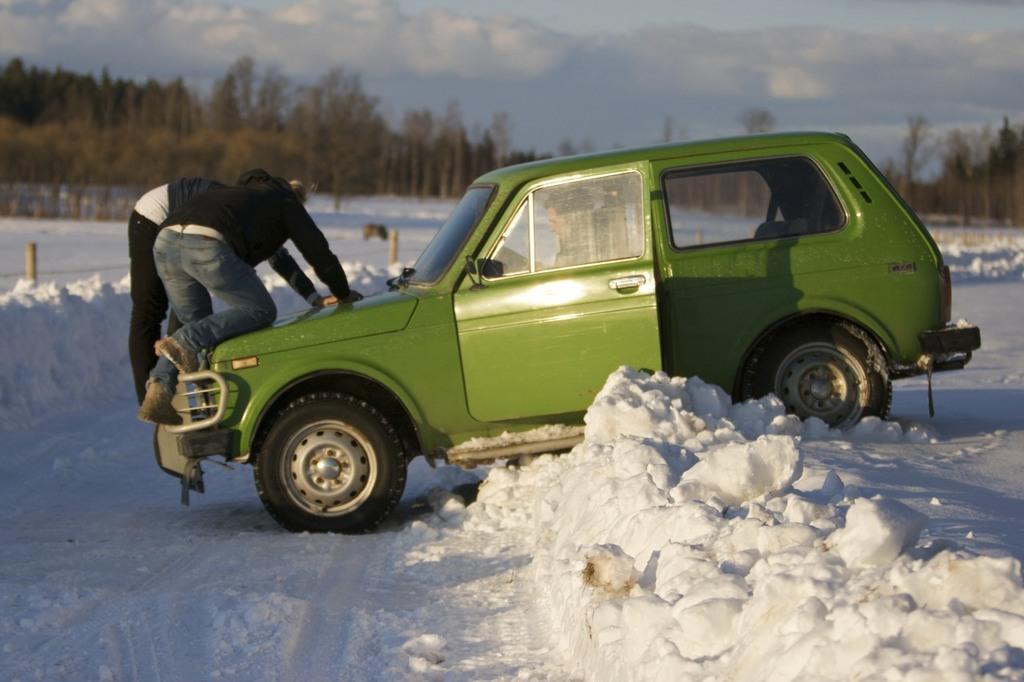Please provide a concise description of this image. In this image we can see a car. Inside the car there is a person. On the car there are two other persons. On the ground there is snow. In the background there are trees and there is sky with clouds. 